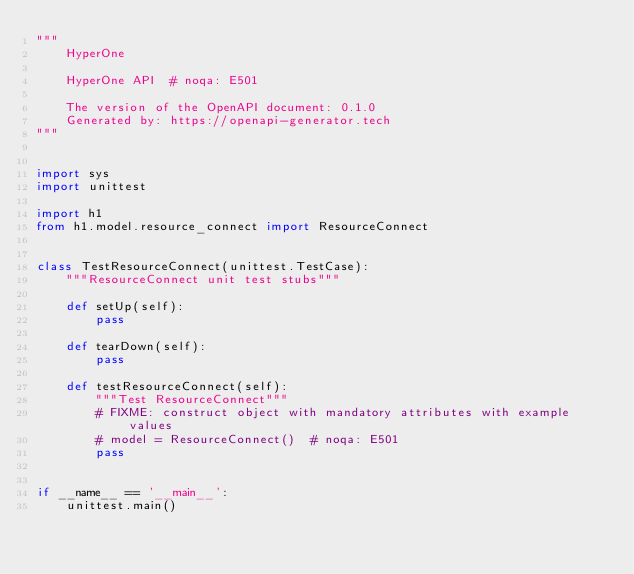<code> <loc_0><loc_0><loc_500><loc_500><_Python_>"""
    HyperOne

    HyperOne API  # noqa: E501

    The version of the OpenAPI document: 0.1.0
    Generated by: https://openapi-generator.tech
"""


import sys
import unittest

import h1
from h1.model.resource_connect import ResourceConnect


class TestResourceConnect(unittest.TestCase):
    """ResourceConnect unit test stubs"""

    def setUp(self):
        pass

    def tearDown(self):
        pass

    def testResourceConnect(self):
        """Test ResourceConnect"""
        # FIXME: construct object with mandatory attributes with example values
        # model = ResourceConnect()  # noqa: E501
        pass


if __name__ == '__main__':
    unittest.main()
</code> 